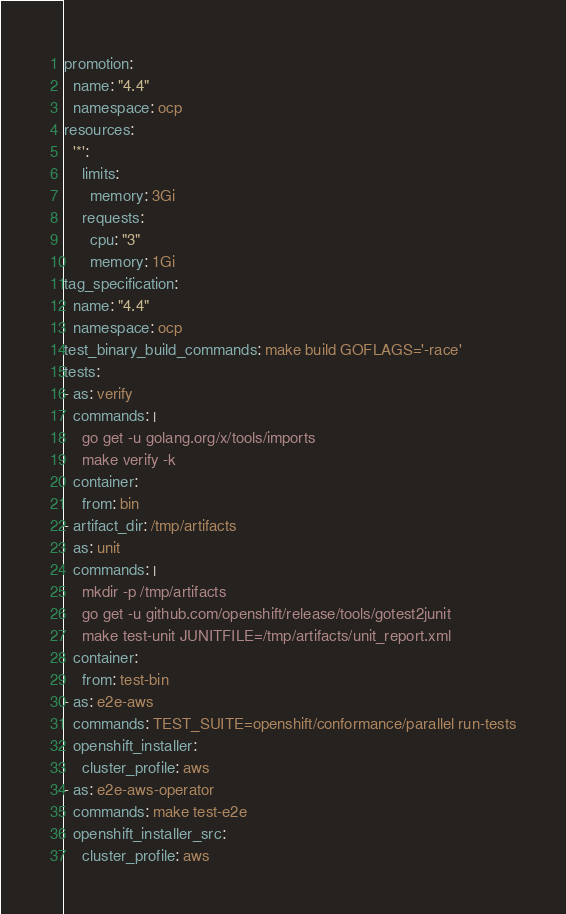<code> <loc_0><loc_0><loc_500><loc_500><_YAML_>promotion:
  name: "4.4"
  namespace: ocp
resources:
  '*':
    limits:
      memory: 3Gi
    requests:
      cpu: "3"
      memory: 1Gi
tag_specification:
  name: "4.4"
  namespace: ocp
test_binary_build_commands: make build GOFLAGS='-race'
tests:
- as: verify
  commands: |
    go get -u golang.org/x/tools/imports
    make verify -k
  container:
    from: bin
- artifact_dir: /tmp/artifacts
  as: unit
  commands: |
    mkdir -p /tmp/artifacts
    go get -u github.com/openshift/release/tools/gotest2junit
    make test-unit JUNITFILE=/tmp/artifacts/unit_report.xml
  container:
    from: test-bin
- as: e2e-aws
  commands: TEST_SUITE=openshift/conformance/parallel run-tests
  openshift_installer:
    cluster_profile: aws
- as: e2e-aws-operator
  commands: make test-e2e
  openshift_installer_src:
    cluster_profile: aws
</code> 